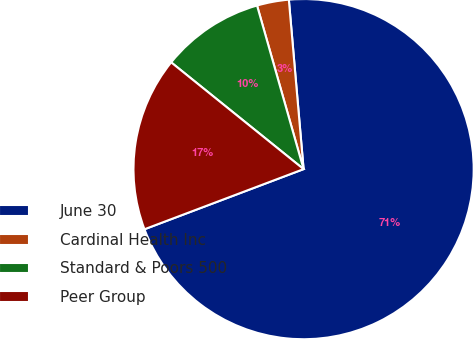Convert chart to OTSL. <chart><loc_0><loc_0><loc_500><loc_500><pie_chart><fcel>June 30<fcel>Cardinal Health Inc<fcel>Standard & Poors 500<fcel>Peer Group<nl><fcel>70.63%<fcel>3.03%<fcel>9.79%<fcel>16.55%<nl></chart> 